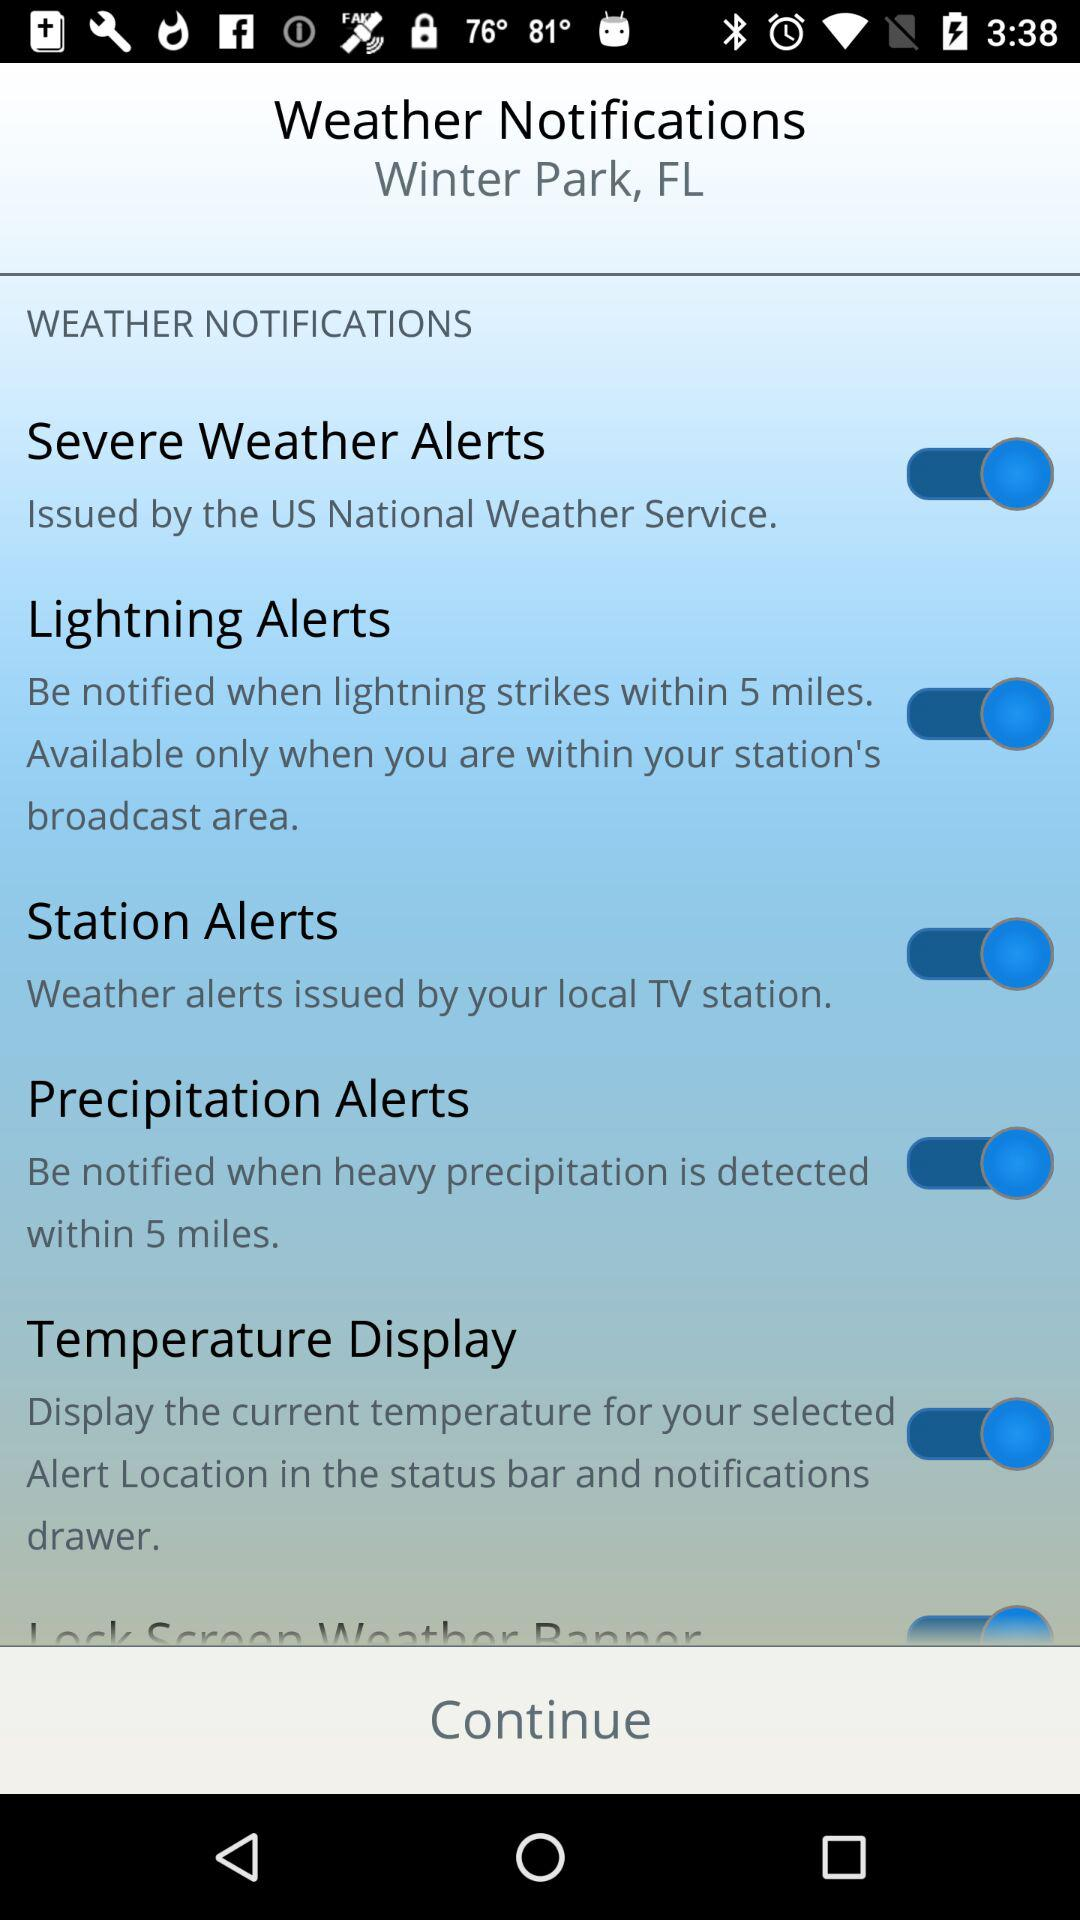What is the status of the "Temperature Display" setting? The status is "on". 